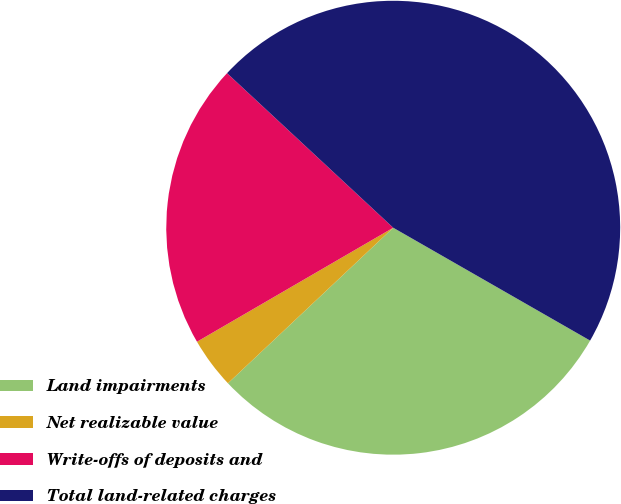Convert chart. <chart><loc_0><loc_0><loc_500><loc_500><pie_chart><fcel>Land impairments<fcel>Net realizable value<fcel>Write-offs of deposits and<fcel>Total land-related charges<nl><fcel>29.7%<fcel>3.64%<fcel>20.3%<fcel>46.36%<nl></chart> 